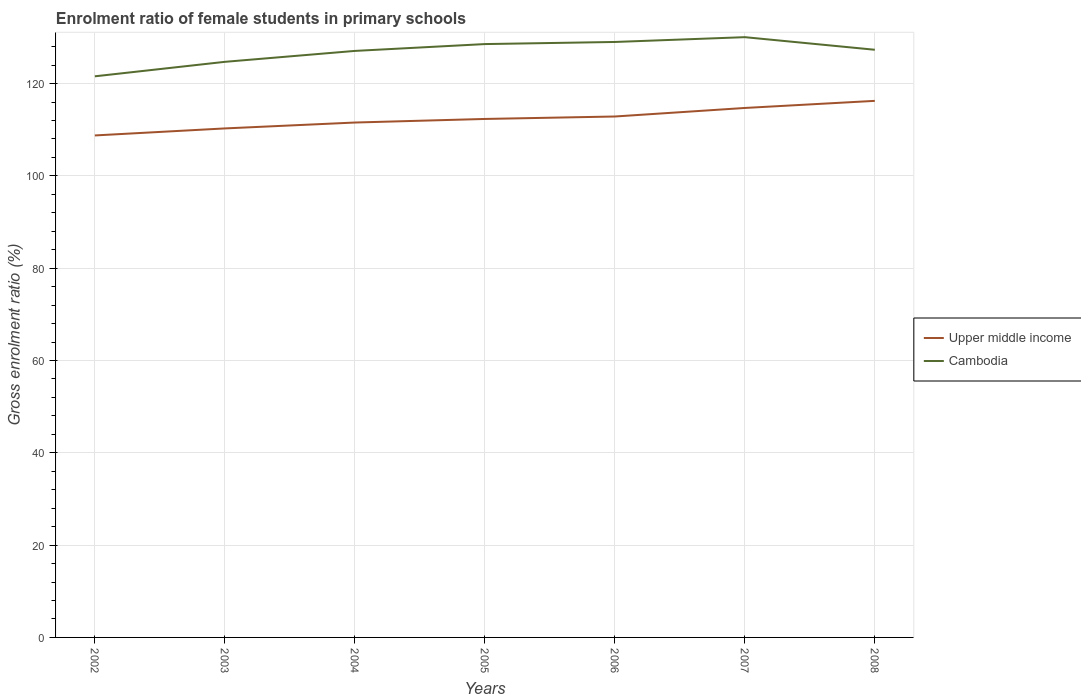Does the line corresponding to Cambodia intersect with the line corresponding to Upper middle income?
Offer a terse response. No. Is the number of lines equal to the number of legend labels?
Provide a short and direct response. Yes. Across all years, what is the maximum enrolment ratio of female students in primary schools in Upper middle income?
Provide a short and direct response. 108.76. In which year was the enrolment ratio of female students in primary schools in Upper middle income maximum?
Your response must be concise. 2002. What is the total enrolment ratio of female students in primary schools in Cambodia in the graph?
Your answer should be compact. -8.48. What is the difference between the highest and the second highest enrolment ratio of female students in primary schools in Cambodia?
Provide a short and direct response. 8.48. What is the difference between the highest and the lowest enrolment ratio of female students in primary schools in Cambodia?
Provide a short and direct response. 5. What is the difference between two consecutive major ticks on the Y-axis?
Your answer should be compact. 20. Where does the legend appear in the graph?
Give a very brief answer. Center right. How many legend labels are there?
Your answer should be very brief. 2. What is the title of the graph?
Give a very brief answer. Enrolment ratio of female students in primary schools. Does "Middle East & North Africa (all income levels)" appear as one of the legend labels in the graph?
Provide a succinct answer. No. What is the label or title of the X-axis?
Keep it short and to the point. Years. What is the Gross enrolment ratio (%) of Upper middle income in 2002?
Your response must be concise. 108.76. What is the Gross enrolment ratio (%) in Cambodia in 2002?
Offer a very short reply. 121.57. What is the Gross enrolment ratio (%) of Upper middle income in 2003?
Your answer should be compact. 110.28. What is the Gross enrolment ratio (%) in Cambodia in 2003?
Give a very brief answer. 124.71. What is the Gross enrolment ratio (%) of Upper middle income in 2004?
Keep it short and to the point. 111.56. What is the Gross enrolment ratio (%) in Cambodia in 2004?
Ensure brevity in your answer.  127.07. What is the Gross enrolment ratio (%) in Upper middle income in 2005?
Your response must be concise. 112.33. What is the Gross enrolment ratio (%) of Cambodia in 2005?
Ensure brevity in your answer.  128.55. What is the Gross enrolment ratio (%) of Upper middle income in 2006?
Give a very brief answer. 112.86. What is the Gross enrolment ratio (%) of Cambodia in 2006?
Provide a succinct answer. 129.01. What is the Gross enrolment ratio (%) in Upper middle income in 2007?
Your response must be concise. 114.71. What is the Gross enrolment ratio (%) of Cambodia in 2007?
Your response must be concise. 130.05. What is the Gross enrolment ratio (%) of Upper middle income in 2008?
Give a very brief answer. 116.25. What is the Gross enrolment ratio (%) in Cambodia in 2008?
Your answer should be very brief. 127.32. Across all years, what is the maximum Gross enrolment ratio (%) in Upper middle income?
Your response must be concise. 116.25. Across all years, what is the maximum Gross enrolment ratio (%) of Cambodia?
Offer a terse response. 130.05. Across all years, what is the minimum Gross enrolment ratio (%) in Upper middle income?
Offer a terse response. 108.76. Across all years, what is the minimum Gross enrolment ratio (%) in Cambodia?
Provide a short and direct response. 121.57. What is the total Gross enrolment ratio (%) of Upper middle income in the graph?
Give a very brief answer. 786.76. What is the total Gross enrolment ratio (%) in Cambodia in the graph?
Your answer should be compact. 888.29. What is the difference between the Gross enrolment ratio (%) in Upper middle income in 2002 and that in 2003?
Make the answer very short. -1.52. What is the difference between the Gross enrolment ratio (%) of Cambodia in 2002 and that in 2003?
Ensure brevity in your answer.  -3.14. What is the difference between the Gross enrolment ratio (%) in Upper middle income in 2002 and that in 2004?
Give a very brief answer. -2.79. What is the difference between the Gross enrolment ratio (%) in Cambodia in 2002 and that in 2004?
Your answer should be compact. -5.5. What is the difference between the Gross enrolment ratio (%) in Upper middle income in 2002 and that in 2005?
Keep it short and to the point. -3.57. What is the difference between the Gross enrolment ratio (%) of Cambodia in 2002 and that in 2005?
Offer a terse response. -6.98. What is the difference between the Gross enrolment ratio (%) of Upper middle income in 2002 and that in 2006?
Your answer should be compact. -4.1. What is the difference between the Gross enrolment ratio (%) of Cambodia in 2002 and that in 2006?
Keep it short and to the point. -7.44. What is the difference between the Gross enrolment ratio (%) of Upper middle income in 2002 and that in 2007?
Provide a succinct answer. -5.95. What is the difference between the Gross enrolment ratio (%) in Cambodia in 2002 and that in 2007?
Your answer should be compact. -8.48. What is the difference between the Gross enrolment ratio (%) of Upper middle income in 2002 and that in 2008?
Provide a short and direct response. -7.49. What is the difference between the Gross enrolment ratio (%) in Cambodia in 2002 and that in 2008?
Offer a terse response. -5.75. What is the difference between the Gross enrolment ratio (%) in Upper middle income in 2003 and that in 2004?
Your answer should be compact. -1.28. What is the difference between the Gross enrolment ratio (%) of Cambodia in 2003 and that in 2004?
Your response must be concise. -2.37. What is the difference between the Gross enrolment ratio (%) in Upper middle income in 2003 and that in 2005?
Keep it short and to the point. -2.05. What is the difference between the Gross enrolment ratio (%) of Cambodia in 2003 and that in 2005?
Make the answer very short. -3.85. What is the difference between the Gross enrolment ratio (%) in Upper middle income in 2003 and that in 2006?
Your answer should be compact. -2.58. What is the difference between the Gross enrolment ratio (%) in Cambodia in 2003 and that in 2006?
Offer a very short reply. -4.3. What is the difference between the Gross enrolment ratio (%) of Upper middle income in 2003 and that in 2007?
Give a very brief answer. -4.43. What is the difference between the Gross enrolment ratio (%) of Cambodia in 2003 and that in 2007?
Give a very brief answer. -5.35. What is the difference between the Gross enrolment ratio (%) in Upper middle income in 2003 and that in 2008?
Offer a terse response. -5.97. What is the difference between the Gross enrolment ratio (%) in Cambodia in 2003 and that in 2008?
Offer a very short reply. -2.62. What is the difference between the Gross enrolment ratio (%) in Upper middle income in 2004 and that in 2005?
Make the answer very short. -0.77. What is the difference between the Gross enrolment ratio (%) of Cambodia in 2004 and that in 2005?
Offer a terse response. -1.48. What is the difference between the Gross enrolment ratio (%) in Upper middle income in 2004 and that in 2006?
Provide a succinct answer. -1.31. What is the difference between the Gross enrolment ratio (%) of Cambodia in 2004 and that in 2006?
Your answer should be very brief. -1.94. What is the difference between the Gross enrolment ratio (%) of Upper middle income in 2004 and that in 2007?
Your answer should be very brief. -3.16. What is the difference between the Gross enrolment ratio (%) of Cambodia in 2004 and that in 2007?
Give a very brief answer. -2.98. What is the difference between the Gross enrolment ratio (%) of Upper middle income in 2004 and that in 2008?
Your response must be concise. -4.7. What is the difference between the Gross enrolment ratio (%) in Cambodia in 2004 and that in 2008?
Ensure brevity in your answer.  -0.25. What is the difference between the Gross enrolment ratio (%) in Upper middle income in 2005 and that in 2006?
Ensure brevity in your answer.  -0.53. What is the difference between the Gross enrolment ratio (%) of Cambodia in 2005 and that in 2006?
Provide a short and direct response. -0.46. What is the difference between the Gross enrolment ratio (%) in Upper middle income in 2005 and that in 2007?
Offer a terse response. -2.38. What is the difference between the Gross enrolment ratio (%) of Cambodia in 2005 and that in 2007?
Your response must be concise. -1.5. What is the difference between the Gross enrolment ratio (%) in Upper middle income in 2005 and that in 2008?
Keep it short and to the point. -3.92. What is the difference between the Gross enrolment ratio (%) of Cambodia in 2005 and that in 2008?
Ensure brevity in your answer.  1.23. What is the difference between the Gross enrolment ratio (%) of Upper middle income in 2006 and that in 2007?
Your response must be concise. -1.85. What is the difference between the Gross enrolment ratio (%) of Cambodia in 2006 and that in 2007?
Your answer should be compact. -1.04. What is the difference between the Gross enrolment ratio (%) in Upper middle income in 2006 and that in 2008?
Keep it short and to the point. -3.39. What is the difference between the Gross enrolment ratio (%) in Cambodia in 2006 and that in 2008?
Your answer should be very brief. 1.69. What is the difference between the Gross enrolment ratio (%) in Upper middle income in 2007 and that in 2008?
Make the answer very short. -1.54. What is the difference between the Gross enrolment ratio (%) in Cambodia in 2007 and that in 2008?
Offer a terse response. 2.73. What is the difference between the Gross enrolment ratio (%) in Upper middle income in 2002 and the Gross enrolment ratio (%) in Cambodia in 2003?
Provide a short and direct response. -15.94. What is the difference between the Gross enrolment ratio (%) of Upper middle income in 2002 and the Gross enrolment ratio (%) of Cambodia in 2004?
Offer a terse response. -18.31. What is the difference between the Gross enrolment ratio (%) in Upper middle income in 2002 and the Gross enrolment ratio (%) in Cambodia in 2005?
Your answer should be very brief. -19.79. What is the difference between the Gross enrolment ratio (%) in Upper middle income in 2002 and the Gross enrolment ratio (%) in Cambodia in 2006?
Offer a very short reply. -20.25. What is the difference between the Gross enrolment ratio (%) in Upper middle income in 2002 and the Gross enrolment ratio (%) in Cambodia in 2007?
Keep it short and to the point. -21.29. What is the difference between the Gross enrolment ratio (%) in Upper middle income in 2002 and the Gross enrolment ratio (%) in Cambodia in 2008?
Ensure brevity in your answer.  -18.56. What is the difference between the Gross enrolment ratio (%) of Upper middle income in 2003 and the Gross enrolment ratio (%) of Cambodia in 2004?
Keep it short and to the point. -16.79. What is the difference between the Gross enrolment ratio (%) in Upper middle income in 2003 and the Gross enrolment ratio (%) in Cambodia in 2005?
Your answer should be compact. -18.27. What is the difference between the Gross enrolment ratio (%) in Upper middle income in 2003 and the Gross enrolment ratio (%) in Cambodia in 2006?
Offer a terse response. -18.73. What is the difference between the Gross enrolment ratio (%) in Upper middle income in 2003 and the Gross enrolment ratio (%) in Cambodia in 2007?
Offer a very short reply. -19.77. What is the difference between the Gross enrolment ratio (%) of Upper middle income in 2003 and the Gross enrolment ratio (%) of Cambodia in 2008?
Provide a succinct answer. -17.04. What is the difference between the Gross enrolment ratio (%) of Upper middle income in 2004 and the Gross enrolment ratio (%) of Cambodia in 2005?
Give a very brief answer. -17. What is the difference between the Gross enrolment ratio (%) in Upper middle income in 2004 and the Gross enrolment ratio (%) in Cambodia in 2006?
Offer a terse response. -17.45. What is the difference between the Gross enrolment ratio (%) in Upper middle income in 2004 and the Gross enrolment ratio (%) in Cambodia in 2007?
Give a very brief answer. -18.5. What is the difference between the Gross enrolment ratio (%) in Upper middle income in 2004 and the Gross enrolment ratio (%) in Cambodia in 2008?
Give a very brief answer. -15.77. What is the difference between the Gross enrolment ratio (%) of Upper middle income in 2005 and the Gross enrolment ratio (%) of Cambodia in 2006?
Ensure brevity in your answer.  -16.68. What is the difference between the Gross enrolment ratio (%) in Upper middle income in 2005 and the Gross enrolment ratio (%) in Cambodia in 2007?
Offer a terse response. -17.72. What is the difference between the Gross enrolment ratio (%) in Upper middle income in 2005 and the Gross enrolment ratio (%) in Cambodia in 2008?
Give a very brief answer. -14.99. What is the difference between the Gross enrolment ratio (%) of Upper middle income in 2006 and the Gross enrolment ratio (%) of Cambodia in 2007?
Provide a short and direct response. -17.19. What is the difference between the Gross enrolment ratio (%) of Upper middle income in 2006 and the Gross enrolment ratio (%) of Cambodia in 2008?
Give a very brief answer. -14.46. What is the difference between the Gross enrolment ratio (%) of Upper middle income in 2007 and the Gross enrolment ratio (%) of Cambodia in 2008?
Offer a terse response. -12.61. What is the average Gross enrolment ratio (%) in Upper middle income per year?
Ensure brevity in your answer.  112.39. What is the average Gross enrolment ratio (%) of Cambodia per year?
Make the answer very short. 126.9. In the year 2002, what is the difference between the Gross enrolment ratio (%) of Upper middle income and Gross enrolment ratio (%) of Cambodia?
Offer a very short reply. -12.81. In the year 2003, what is the difference between the Gross enrolment ratio (%) in Upper middle income and Gross enrolment ratio (%) in Cambodia?
Ensure brevity in your answer.  -14.43. In the year 2004, what is the difference between the Gross enrolment ratio (%) of Upper middle income and Gross enrolment ratio (%) of Cambodia?
Give a very brief answer. -15.52. In the year 2005, what is the difference between the Gross enrolment ratio (%) of Upper middle income and Gross enrolment ratio (%) of Cambodia?
Make the answer very short. -16.22. In the year 2006, what is the difference between the Gross enrolment ratio (%) of Upper middle income and Gross enrolment ratio (%) of Cambodia?
Offer a terse response. -16.15. In the year 2007, what is the difference between the Gross enrolment ratio (%) of Upper middle income and Gross enrolment ratio (%) of Cambodia?
Your response must be concise. -15.34. In the year 2008, what is the difference between the Gross enrolment ratio (%) in Upper middle income and Gross enrolment ratio (%) in Cambodia?
Give a very brief answer. -11.07. What is the ratio of the Gross enrolment ratio (%) in Upper middle income in 2002 to that in 2003?
Your answer should be compact. 0.99. What is the ratio of the Gross enrolment ratio (%) in Cambodia in 2002 to that in 2003?
Your response must be concise. 0.97. What is the ratio of the Gross enrolment ratio (%) in Upper middle income in 2002 to that in 2004?
Make the answer very short. 0.97. What is the ratio of the Gross enrolment ratio (%) of Cambodia in 2002 to that in 2004?
Keep it short and to the point. 0.96. What is the ratio of the Gross enrolment ratio (%) in Upper middle income in 2002 to that in 2005?
Ensure brevity in your answer.  0.97. What is the ratio of the Gross enrolment ratio (%) of Cambodia in 2002 to that in 2005?
Your response must be concise. 0.95. What is the ratio of the Gross enrolment ratio (%) of Upper middle income in 2002 to that in 2006?
Provide a succinct answer. 0.96. What is the ratio of the Gross enrolment ratio (%) of Cambodia in 2002 to that in 2006?
Provide a succinct answer. 0.94. What is the ratio of the Gross enrolment ratio (%) in Upper middle income in 2002 to that in 2007?
Your answer should be very brief. 0.95. What is the ratio of the Gross enrolment ratio (%) of Cambodia in 2002 to that in 2007?
Your response must be concise. 0.93. What is the ratio of the Gross enrolment ratio (%) of Upper middle income in 2002 to that in 2008?
Provide a succinct answer. 0.94. What is the ratio of the Gross enrolment ratio (%) of Cambodia in 2002 to that in 2008?
Offer a terse response. 0.95. What is the ratio of the Gross enrolment ratio (%) of Upper middle income in 2003 to that in 2004?
Ensure brevity in your answer.  0.99. What is the ratio of the Gross enrolment ratio (%) of Cambodia in 2003 to that in 2004?
Give a very brief answer. 0.98. What is the ratio of the Gross enrolment ratio (%) in Upper middle income in 2003 to that in 2005?
Your answer should be compact. 0.98. What is the ratio of the Gross enrolment ratio (%) of Cambodia in 2003 to that in 2005?
Provide a short and direct response. 0.97. What is the ratio of the Gross enrolment ratio (%) of Upper middle income in 2003 to that in 2006?
Your response must be concise. 0.98. What is the ratio of the Gross enrolment ratio (%) in Cambodia in 2003 to that in 2006?
Offer a terse response. 0.97. What is the ratio of the Gross enrolment ratio (%) in Upper middle income in 2003 to that in 2007?
Give a very brief answer. 0.96. What is the ratio of the Gross enrolment ratio (%) of Cambodia in 2003 to that in 2007?
Your response must be concise. 0.96. What is the ratio of the Gross enrolment ratio (%) of Upper middle income in 2003 to that in 2008?
Provide a short and direct response. 0.95. What is the ratio of the Gross enrolment ratio (%) of Cambodia in 2003 to that in 2008?
Offer a very short reply. 0.98. What is the ratio of the Gross enrolment ratio (%) in Cambodia in 2004 to that in 2005?
Your answer should be compact. 0.99. What is the ratio of the Gross enrolment ratio (%) of Upper middle income in 2004 to that in 2006?
Make the answer very short. 0.99. What is the ratio of the Gross enrolment ratio (%) in Cambodia in 2004 to that in 2006?
Give a very brief answer. 0.98. What is the ratio of the Gross enrolment ratio (%) in Upper middle income in 2004 to that in 2007?
Ensure brevity in your answer.  0.97. What is the ratio of the Gross enrolment ratio (%) of Cambodia in 2004 to that in 2007?
Your response must be concise. 0.98. What is the ratio of the Gross enrolment ratio (%) of Upper middle income in 2004 to that in 2008?
Your response must be concise. 0.96. What is the ratio of the Gross enrolment ratio (%) in Cambodia in 2005 to that in 2006?
Your response must be concise. 1. What is the ratio of the Gross enrolment ratio (%) in Upper middle income in 2005 to that in 2007?
Provide a short and direct response. 0.98. What is the ratio of the Gross enrolment ratio (%) of Upper middle income in 2005 to that in 2008?
Offer a terse response. 0.97. What is the ratio of the Gross enrolment ratio (%) of Cambodia in 2005 to that in 2008?
Your answer should be compact. 1.01. What is the ratio of the Gross enrolment ratio (%) in Upper middle income in 2006 to that in 2007?
Provide a short and direct response. 0.98. What is the ratio of the Gross enrolment ratio (%) in Cambodia in 2006 to that in 2007?
Your response must be concise. 0.99. What is the ratio of the Gross enrolment ratio (%) of Upper middle income in 2006 to that in 2008?
Make the answer very short. 0.97. What is the ratio of the Gross enrolment ratio (%) in Cambodia in 2006 to that in 2008?
Make the answer very short. 1.01. What is the ratio of the Gross enrolment ratio (%) of Cambodia in 2007 to that in 2008?
Your answer should be compact. 1.02. What is the difference between the highest and the second highest Gross enrolment ratio (%) in Upper middle income?
Make the answer very short. 1.54. What is the difference between the highest and the second highest Gross enrolment ratio (%) of Cambodia?
Offer a very short reply. 1.04. What is the difference between the highest and the lowest Gross enrolment ratio (%) of Upper middle income?
Ensure brevity in your answer.  7.49. What is the difference between the highest and the lowest Gross enrolment ratio (%) of Cambodia?
Your answer should be compact. 8.48. 